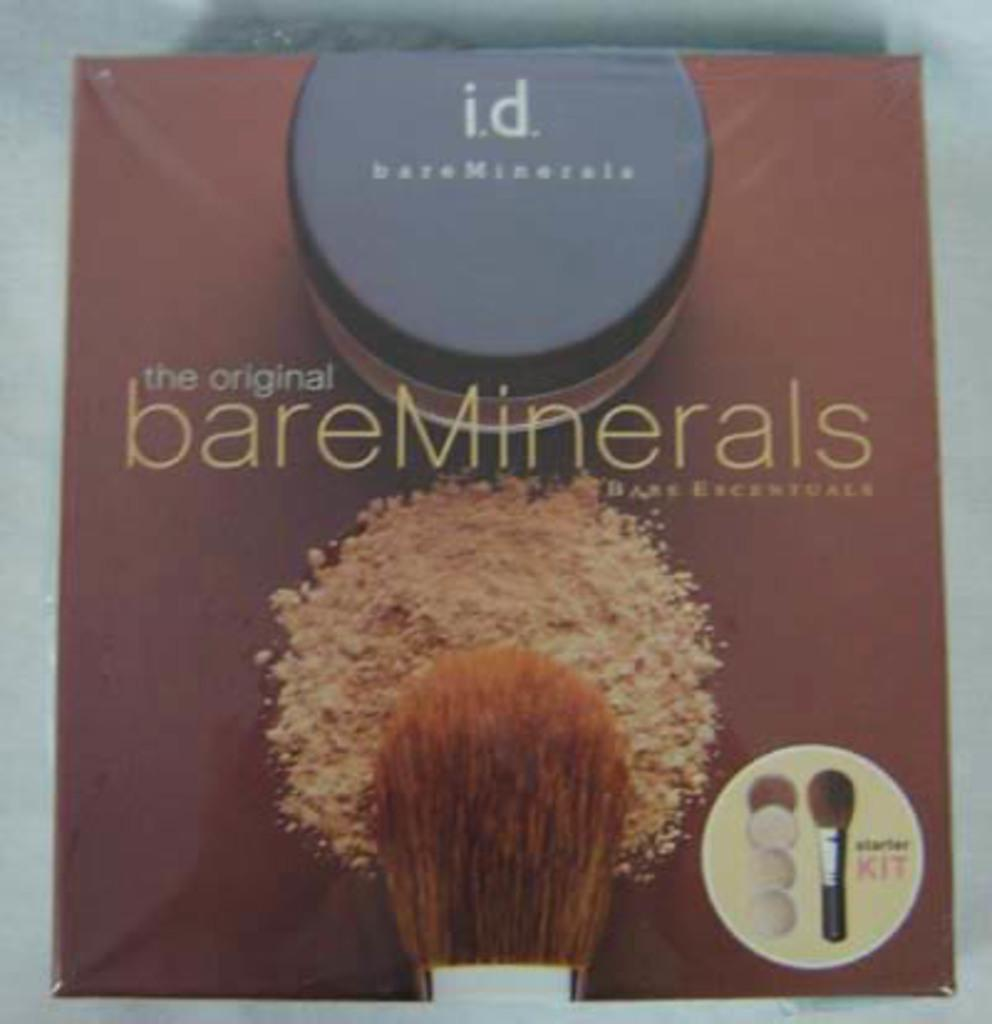Provide a one-sentence caption for the provided image. Bare Minerals starter kit including makeup and brush/. 